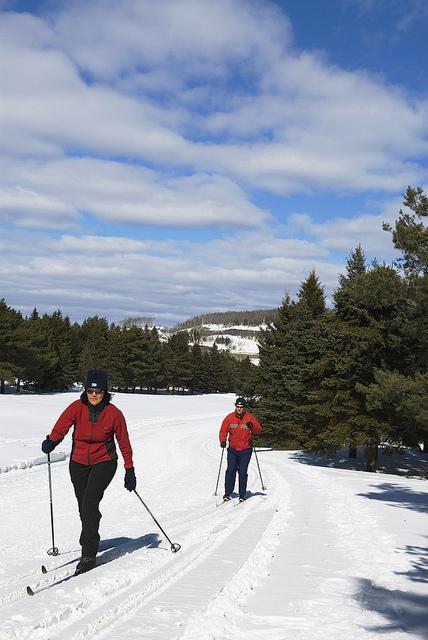How many athletes?
Give a very brief answer. 2. How many people are in the picture?
Give a very brief answer. 2. How many vases are shown?
Give a very brief answer. 0. 